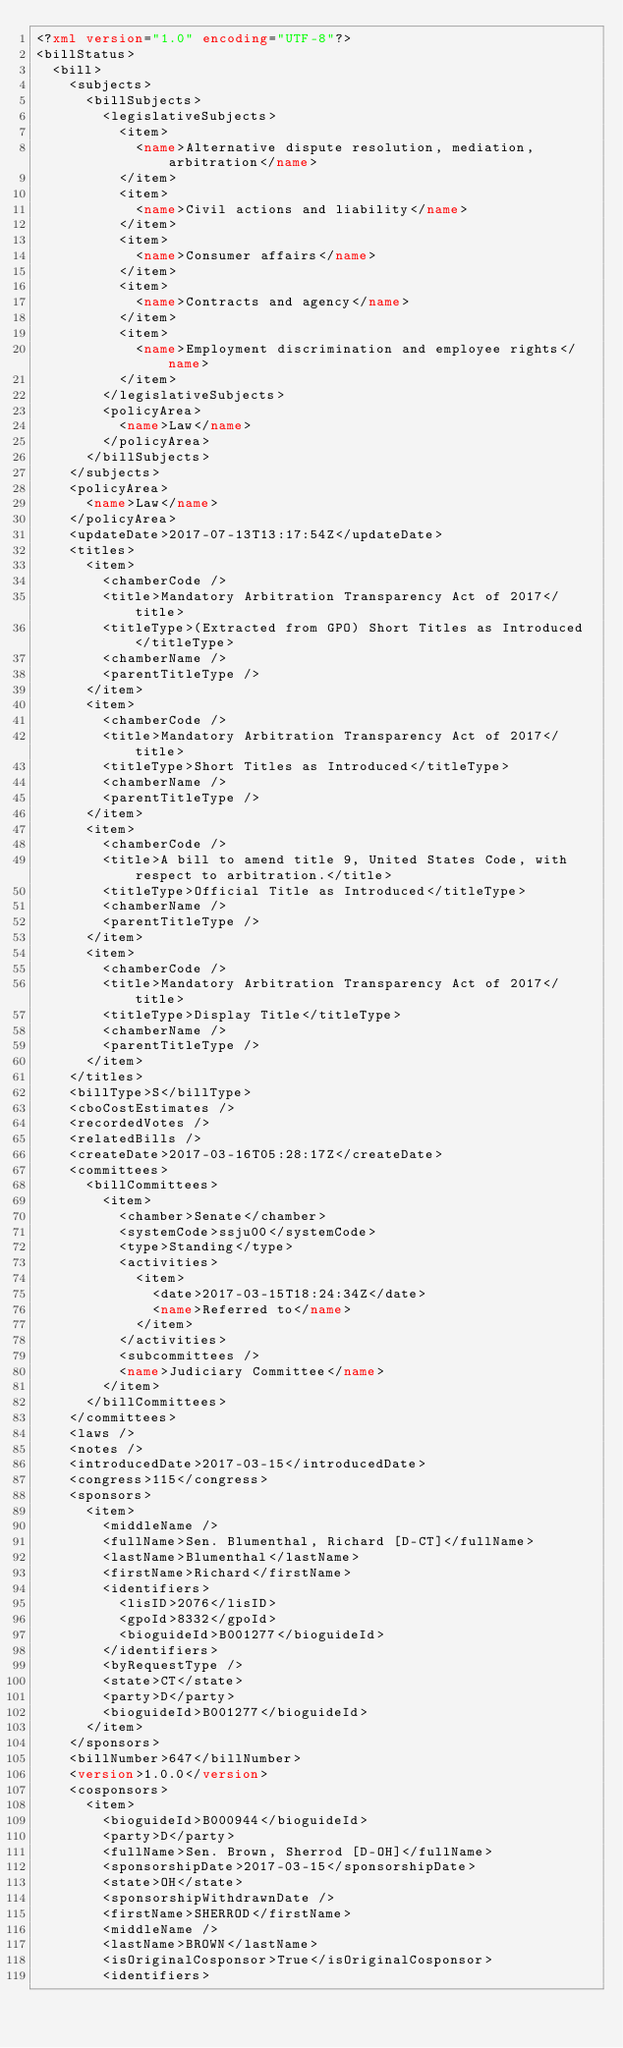<code> <loc_0><loc_0><loc_500><loc_500><_XML_><?xml version="1.0" encoding="UTF-8"?>
<billStatus>
  <bill>
    <subjects>
      <billSubjects>
        <legislativeSubjects>
          <item>
            <name>Alternative dispute resolution, mediation, arbitration</name>
          </item>
          <item>
            <name>Civil actions and liability</name>
          </item>
          <item>
            <name>Consumer affairs</name>
          </item>
          <item>
            <name>Contracts and agency</name>
          </item>
          <item>
            <name>Employment discrimination and employee rights</name>
          </item>
        </legislativeSubjects>
        <policyArea>
          <name>Law</name>
        </policyArea>
      </billSubjects>
    </subjects>
    <policyArea>
      <name>Law</name>
    </policyArea>
    <updateDate>2017-07-13T13:17:54Z</updateDate>
    <titles>
      <item>
        <chamberCode />
        <title>Mandatory Arbitration Transparency Act of 2017</title>
        <titleType>(Extracted from GPO) Short Titles as Introduced</titleType>
        <chamberName />
        <parentTitleType />
      </item>
      <item>
        <chamberCode />
        <title>Mandatory Arbitration Transparency Act of 2017</title>
        <titleType>Short Titles as Introduced</titleType>
        <chamberName />
        <parentTitleType />
      </item>
      <item>
        <chamberCode />
        <title>A bill to amend title 9, United States Code, with respect to arbitration.</title>
        <titleType>Official Title as Introduced</titleType>
        <chamberName />
        <parentTitleType />
      </item>
      <item>
        <chamberCode />
        <title>Mandatory Arbitration Transparency Act of 2017</title>
        <titleType>Display Title</titleType>
        <chamberName />
        <parentTitleType />
      </item>
    </titles>
    <billType>S</billType>
    <cboCostEstimates />
    <recordedVotes />
    <relatedBills />
    <createDate>2017-03-16T05:28:17Z</createDate>
    <committees>
      <billCommittees>
        <item>
          <chamber>Senate</chamber>
          <systemCode>ssju00</systemCode>
          <type>Standing</type>
          <activities>
            <item>
              <date>2017-03-15T18:24:34Z</date>
              <name>Referred to</name>
            </item>
          </activities>
          <subcommittees />
          <name>Judiciary Committee</name>
        </item>
      </billCommittees>
    </committees>
    <laws />
    <notes />
    <introducedDate>2017-03-15</introducedDate>
    <congress>115</congress>
    <sponsors>
      <item>
        <middleName />
        <fullName>Sen. Blumenthal, Richard [D-CT]</fullName>
        <lastName>Blumenthal</lastName>
        <firstName>Richard</firstName>
        <identifiers>
          <lisID>2076</lisID>
          <gpoId>8332</gpoId>
          <bioguideId>B001277</bioguideId>
        </identifiers>
        <byRequestType />
        <state>CT</state>
        <party>D</party>
        <bioguideId>B001277</bioguideId>
      </item>
    </sponsors>
    <billNumber>647</billNumber>
    <version>1.0.0</version>
    <cosponsors>
      <item>
        <bioguideId>B000944</bioguideId>
        <party>D</party>
        <fullName>Sen. Brown, Sherrod [D-OH]</fullName>
        <sponsorshipDate>2017-03-15</sponsorshipDate>
        <state>OH</state>
        <sponsorshipWithdrawnDate />
        <firstName>SHERROD</firstName>
        <middleName />
        <lastName>BROWN</lastName>
        <isOriginalCosponsor>True</isOriginalCosponsor>
        <identifiers></code> 